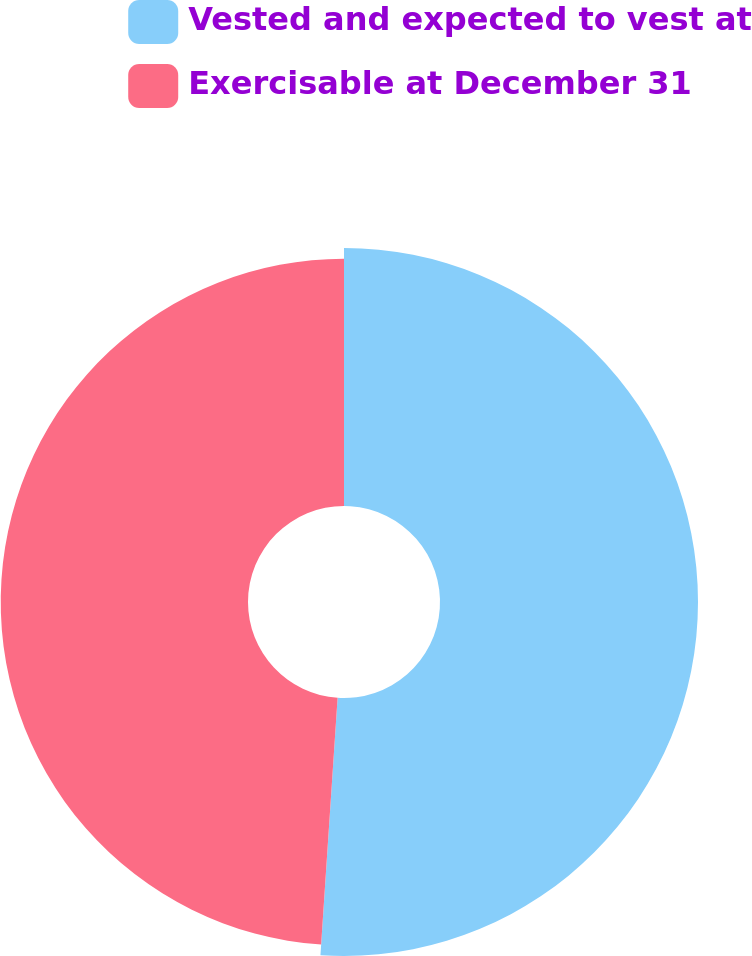<chart> <loc_0><loc_0><loc_500><loc_500><pie_chart><fcel>Vested and expected to vest at<fcel>Exercisable at December 31<nl><fcel>51.06%<fcel>48.94%<nl></chart> 